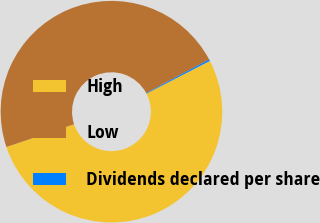<chart> <loc_0><loc_0><loc_500><loc_500><pie_chart><fcel>High<fcel>Low<fcel>Dividends declared per share<nl><fcel>52.42%<fcel>47.35%<fcel>0.23%<nl></chart> 